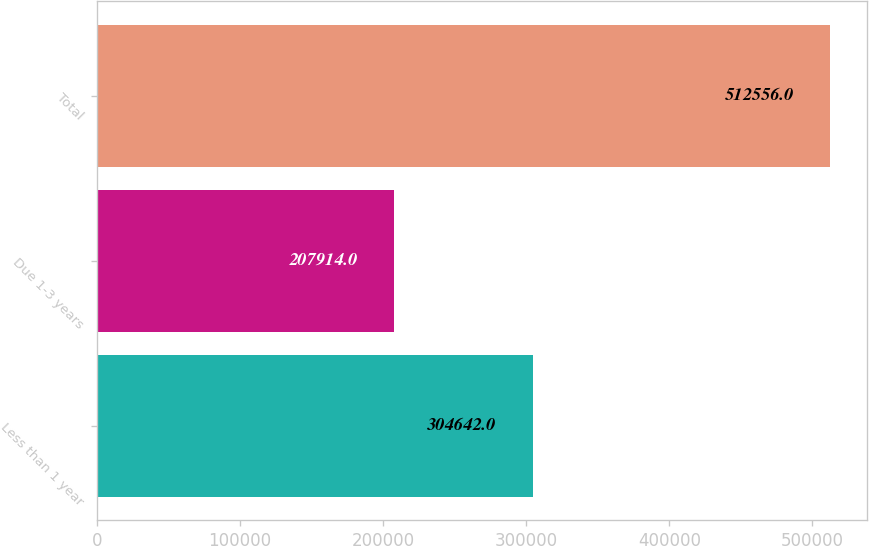Convert chart. <chart><loc_0><loc_0><loc_500><loc_500><bar_chart><fcel>Less than 1 year<fcel>Due 1-3 years<fcel>Total<nl><fcel>304642<fcel>207914<fcel>512556<nl></chart> 